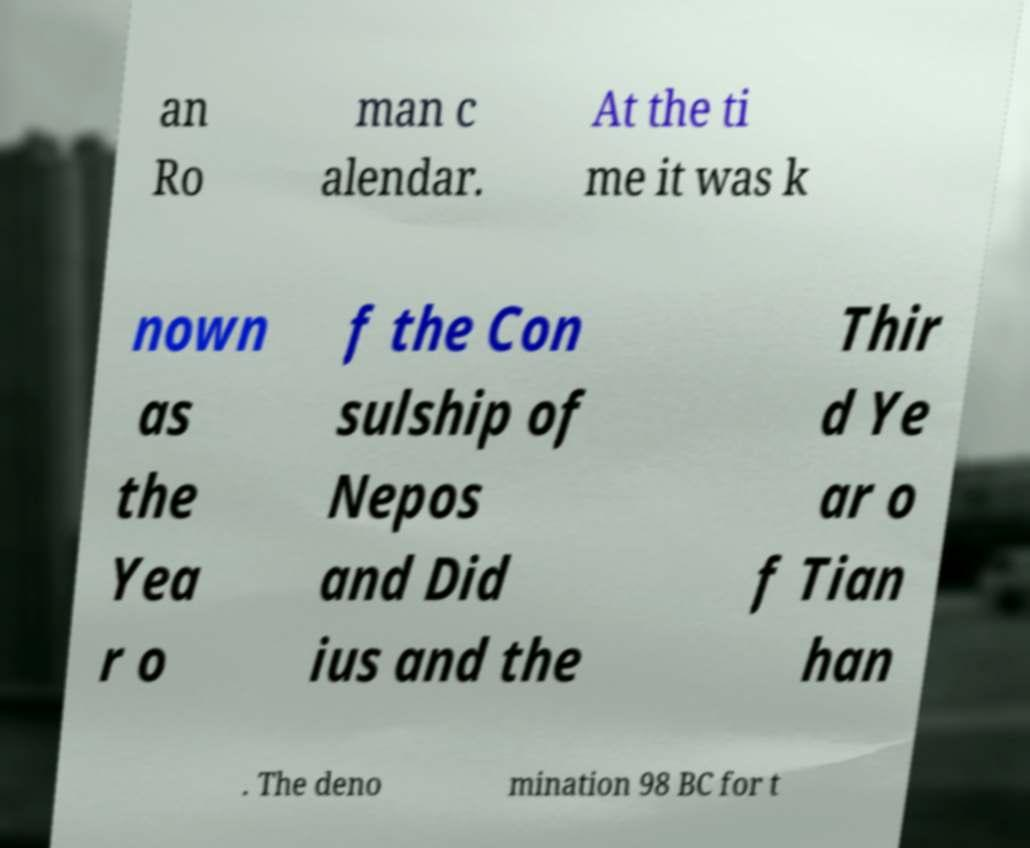Could you extract and type out the text from this image? an Ro man c alendar. At the ti me it was k nown as the Yea r o f the Con sulship of Nepos and Did ius and the Thir d Ye ar o f Tian han . The deno mination 98 BC for t 